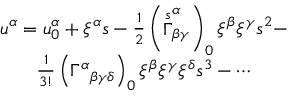<formula> <loc_0><loc_0><loc_500><loc_500>\begin{array} { c } { { u ^ { \alpha } = u _ { 0 } ^ { \alpha } + \xi ^ { \alpha } s - \frac { 1 } { 2 } \left ( \stackrel { s } { \Gamma } _ { \beta \gamma } ^ { \alpha } \right ) _ { 0 } \xi ^ { \beta } \xi ^ { \gamma } s ^ { 2 } - } } \\ { { \frac { 1 } 3 ! } \left ( \Gamma ^ { \alpha _ { \beta \gamma \delta } \right ) _ { 0 } \xi ^ { \beta } \xi ^ { \gamma } \xi ^ { \delta } s ^ { 3 } - \cdots } } \end{array}</formula> 